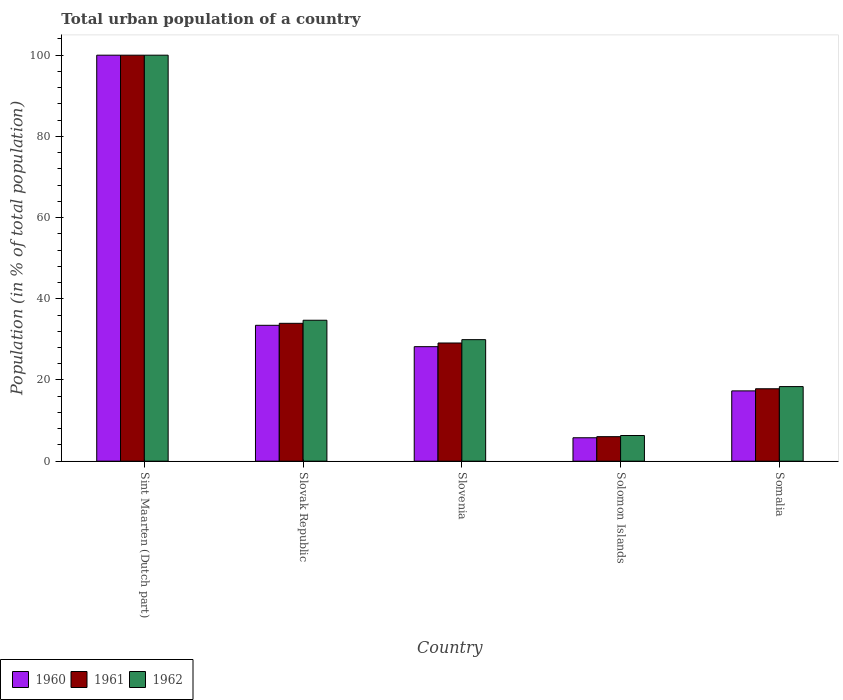How many different coloured bars are there?
Provide a short and direct response. 3. How many groups of bars are there?
Provide a short and direct response. 5. Are the number of bars per tick equal to the number of legend labels?
Offer a terse response. Yes. Are the number of bars on each tick of the X-axis equal?
Keep it short and to the point. Yes. What is the label of the 2nd group of bars from the left?
Offer a terse response. Slovak Republic. What is the urban population in 1960 in Somalia?
Offer a very short reply. 17.31. Across all countries, what is the minimum urban population in 1961?
Your answer should be compact. 6.04. In which country was the urban population in 1962 maximum?
Give a very brief answer. Sint Maarten (Dutch part). In which country was the urban population in 1961 minimum?
Give a very brief answer. Solomon Islands. What is the total urban population in 1962 in the graph?
Your answer should be very brief. 189.34. What is the difference between the urban population in 1961 in Slovenia and that in Somalia?
Offer a terse response. 11.27. What is the difference between the urban population in 1962 in Somalia and the urban population in 1960 in Slovenia?
Provide a short and direct response. -9.83. What is the average urban population in 1960 per country?
Provide a short and direct response. 36.95. What is the difference between the urban population of/in 1961 and urban population of/in 1960 in Solomon Islands?
Give a very brief answer. 0.27. In how many countries, is the urban population in 1960 greater than 80 %?
Offer a very short reply. 1. What is the ratio of the urban population in 1962 in Sint Maarten (Dutch part) to that in Slovak Republic?
Make the answer very short. 2.88. Is the difference between the urban population in 1961 in Slovak Republic and Solomon Islands greater than the difference between the urban population in 1960 in Slovak Republic and Solomon Islands?
Keep it short and to the point. Yes. What is the difference between the highest and the second highest urban population in 1960?
Provide a short and direct response. -66.54. What is the difference between the highest and the lowest urban population in 1962?
Provide a succinct answer. 93.68. What does the 3rd bar from the right in Slovak Republic represents?
Offer a terse response. 1960. Are all the bars in the graph horizontal?
Give a very brief answer. No. How many countries are there in the graph?
Offer a very short reply. 5. Where does the legend appear in the graph?
Offer a very short reply. Bottom left. How many legend labels are there?
Provide a succinct answer. 3. What is the title of the graph?
Offer a very short reply. Total urban population of a country. Does "1981" appear as one of the legend labels in the graph?
Give a very brief answer. No. What is the label or title of the X-axis?
Your answer should be compact. Country. What is the label or title of the Y-axis?
Your answer should be very brief. Population (in % of total population). What is the Population (in % of total population) in 1960 in Slovak Republic?
Offer a very short reply. 33.46. What is the Population (in % of total population) in 1961 in Slovak Republic?
Make the answer very short. 33.95. What is the Population (in % of total population) of 1962 in Slovak Republic?
Provide a succinct answer. 34.71. What is the Population (in % of total population) of 1960 in Slovenia?
Make the answer very short. 28.2. What is the Population (in % of total population) in 1961 in Slovenia?
Offer a terse response. 29.11. What is the Population (in % of total population) of 1962 in Slovenia?
Keep it short and to the point. 29.93. What is the Population (in % of total population) of 1960 in Solomon Islands?
Make the answer very short. 5.77. What is the Population (in % of total population) of 1961 in Solomon Islands?
Provide a succinct answer. 6.04. What is the Population (in % of total population) in 1962 in Solomon Islands?
Make the answer very short. 6.32. What is the Population (in % of total population) of 1960 in Somalia?
Make the answer very short. 17.31. What is the Population (in % of total population) of 1961 in Somalia?
Ensure brevity in your answer.  17.84. What is the Population (in % of total population) in 1962 in Somalia?
Offer a terse response. 18.37. Across all countries, what is the maximum Population (in % of total population) in 1961?
Provide a short and direct response. 100. Across all countries, what is the minimum Population (in % of total population) in 1960?
Offer a terse response. 5.77. Across all countries, what is the minimum Population (in % of total population) in 1961?
Your answer should be compact. 6.04. Across all countries, what is the minimum Population (in % of total population) in 1962?
Keep it short and to the point. 6.32. What is the total Population (in % of total population) of 1960 in the graph?
Your response must be concise. 184.75. What is the total Population (in % of total population) of 1961 in the graph?
Make the answer very short. 186.93. What is the total Population (in % of total population) in 1962 in the graph?
Offer a terse response. 189.34. What is the difference between the Population (in % of total population) in 1960 in Sint Maarten (Dutch part) and that in Slovak Republic?
Your answer should be compact. 66.54. What is the difference between the Population (in % of total population) of 1961 in Sint Maarten (Dutch part) and that in Slovak Republic?
Provide a short and direct response. 66.05. What is the difference between the Population (in % of total population) of 1962 in Sint Maarten (Dutch part) and that in Slovak Republic?
Make the answer very short. 65.29. What is the difference between the Population (in % of total population) of 1960 in Sint Maarten (Dutch part) and that in Slovenia?
Make the answer very short. 71.8. What is the difference between the Population (in % of total population) in 1961 in Sint Maarten (Dutch part) and that in Slovenia?
Make the answer very short. 70.89. What is the difference between the Population (in % of total population) in 1962 in Sint Maarten (Dutch part) and that in Slovenia?
Provide a succinct answer. 70.07. What is the difference between the Population (in % of total population) of 1960 in Sint Maarten (Dutch part) and that in Solomon Islands?
Offer a terse response. 94.23. What is the difference between the Population (in % of total population) in 1961 in Sint Maarten (Dutch part) and that in Solomon Islands?
Provide a succinct answer. 93.96. What is the difference between the Population (in % of total population) of 1962 in Sint Maarten (Dutch part) and that in Solomon Islands?
Offer a very short reply. 93.68. What is the difference between the Population (in % of total population) of 1960 in Sint Maarten (Dutch part) and that in Somalia?
Keep it short and to the point. 82.69. What is the difference between the Population (in % of total population) in 1961 in Sint Maarten (Dutch part) and that in Somalia?
Offer a terse response. 82.17. What is the difference between the Population (in % of total population) of 1962 in Sint Maarten (Dutch part) and that in Somalia?
Give a very brief answer. 81.63. What is the difference between the Population (in % of total population) of 1960 in Slovak Republic and that in Slovenia?
Ensure brevity in your answer.  5.26. What is the difference between the Population (in % of total population) of 1961 in Slovak Republic and that in Slovenia?
Your response must be concise. 4.85. What is the difference between the Population (in % of total population) of 1962 in Slovak Republic and that in Slovenia?
Provide a succinct answer. 4.78. What is the difference between the Population (in % of total population) of 1960 in Slovak Republic and that in Solomon Islands?
Your response must be concise. 27.7. What is the difference between the Population (in % of total population) in 1961 in Slovak Republic and that in Solomon Islands?
Ensure brevity in your answer.  27.91. What is the difference between the Population (in % of total population) in 1962 in Slovak Republic and that in Solomon Islands?
Offer a terse response. 28.39. What is the difference between the Population (in % of total population) of 1960 in Slovak Republic and that in Somalia?
Ensure brevity in your answer.  16.15. What is the difference between the Population (in % of total population) in 1961 in Slovak Republic and that in Somalia?
Your response must be concise. 16.12. What is the difference between the Population (in % of total population) of 1962 in Slovak Republic and that in Somalia?
Your answer should be compact. 16.34. What is the difference between the Population (in % of total population) in 1960 in Slovenia and that in Solomon Islands?
Offer a very short reply. 22.44. What is the difference between the Population (in % of total population) in 1961 in Slovenia and that in Solomon Islands?
Provide a succinct answer. 23.07. What is the difference between the Population (in % of total population) in 1962 in Slovenia and that in Solomon Islands?
Provide a short and direct response. 23.61. What is the difference between the Population (in % of total population) in 1960 in Slovenia and that in Somalia?
Provide a short and direct response. 10.89. What is the difference between the Population (in % of total population) of 1961 in Slovenia and that in Somalia?
Offer a very short reply. 11.27. What is the difference between the Population (in % of total population) of 1962 in Slovenia and that in Somalia?
Provide a succinct answer. 11.56. What is the difference between the Population (in % of total population) of 1960 in Solomon Islands and that in Somalia?
Offer a terse response. -11.54. What is the difference between the Population (in % of total population) in 1961 in Solomon Islands and that in Somalia?
Provide a succinct answer. -11.8. What is the difference between the Population (in % of total population) in 1962 in Solomon Islands and that in Somalia?
Offer a very short reply. -12.05. What is the difference between the Population (in % of total population) of 1960 in Sint Maarten (Dutch part) and the Population (in % of total population) of 1961 in Slovak Republic?
Ensure brevity in your answer.  66.05. What is the difference between the Population (in % of total population) of 1960 in Sint Maarten (Dutch part) and the Population (in % of total population) of 1962 in Slovak Republic?
Make the answer very short. 65.29. What is the difference between the Population (in % of total population) in 1961 in Sint Maarten (Dutch part) and the Population (in % of total population) in 1962 in Slovak Republic?
Offer a very short reply. 65.29. What is the difference between the Population (in % of total population) of 1960 in Sint Maarten (Dutch part) and the Population (in % of total population) of 1961 in Slovenia?
Keep it short and to the point. 70.89. What is the difference between the Population (in % of total population) of 1960 in Sint Maarten (Dutch part) and the Population (in % of total population) of 1962 in Slovenia?
Make the answer very short. 70.07. What is the difference between the Population (in % of total population) in 1961 in Sint Maarten (Dutch part) and the Population (in % of total population) in 1962 in Slovenia?
Provide a short and direct response. 70.07. What is the difference between the Population (in % of total population) of 1960 in Sint Maarten (Dutch part) and the Population (in % of total population) of 1961 in Solomon Islands?
Your answer should be compact. 93.96. What is the difference between the Population (in % of total population) in 1960 in Sint Maarten (Dutch part) and the Population (in % of total population) in 1962 in Solomon Islands?
Give a very brief answer. 93.68. What is the difference between the Population (in % of total population) of 1961 in Sint Maarten (Dutch part) and the Population (in % of total population) of 1962 in Solomon Islands?
Provide a short and direct response. 93.68. What is the difference between the Population (in % of total population) of 1960 in Sint Maarten (Dutch part) and the Population (in % of total population) of 1961 in Somalia?
Your answer should be very brief. 82.17. What is the difference between the Population (in % of total population) in 1960 in Sint Maarten (Dutch part) and the Population (in % of total population) in 1962 in Somalia?
Your answer should be compact. 81.63. What is the difference between the Population (in % of total population) in 1961 in Sint Maarten (Dutch part) and the Population (in % of total population) in 1962 in Somalia?
Offer a terse response. 81.63. What is the difference between the Population (in % of total population) of 1960 in Slovak Republic and the Population (in % of total population) of 1961 in Slovenia?
Your answer should be compact. 4.36. What is the difference between the Population (in % of total population) in 1960 in Slovak Republic and the Population (in % of total population) in 1962 in Slovenia?
Keep it short and to the point. 3.53. What is the difference between the Population (in % of total population) of 1961 in Slovak Republic and the Population (in % of total population) of 1962 in Slovenia?
Provide a succinct answer. 4.02. What is the difference between the Population (in % of total population) of 1960 in Slovak Republic and the Population (in % of total population) of 1961 in Solomon Islands?
Give a very brief answer. 27.43. What is the difference between the Population (in % of total population) in 1960 in Slovak Republic and the Population (in % of total population) in 1962 in Solomon Islands?
Ensure brevity in your answer.  27.14. What is the difference between the Population (in % of total population) of 1961 in Slovak Republic and the Population (in % of total population) of 1962 in Solomon Islands?
Give a very brief answer. 27.63. What is the difference between the Population (in % of total population) in 1960 in Slovak Republic and the Population (in % of total population) in 1961 in Somalia?
Your answer should be compact. 15.63. What is the difference between the Population (in % of total population) in 1960 in Slovak Republic and the Population (in % of total population) in 1962 in Somalia?
Your answer should be very brief. 15.09. What is the difference between the Population (in % of total population) of 1961 in Slovak Republic and the Population (in % of total population) of 1962 in Somalia?
Give a very brief answer. 15.58. What is the difference between the Population (in % of total population) of 1960 in Slovenia and the Population (in % of total population) of 1961 in Solomon Islands?
Make the answer very short. 22.17. What is the difference between the Population (in % of total population) of 1960 in Slovenia and the Population (in % of total population) of 1962 in Solomon Islands?
Provide a short and direct response. 21.88. What is the difference between the Population (in % of total population) in 1961 in Slovenia and the Population (in % of total population) in 1962 in Solomon Islands?
Ensure brevity in your answer.  22.79. What is the difference between the Population (in % of total population) in 1960 in Slovenia and the Population (in % of total population) in 1961 in Somalia?
Make the answer very short. 10.37. What is the difference between the Population (in % of total population) in 1960 in Slovenia and the Population (in % of total population) in 1962 in Somalia?
Keep it short and to the point. 9.83. What is the difference between the Population (in % of total population) of 1961 in Slovenia and the Population (in % of total population) of 1962 in Somalia?
Your answer should be compact. 10.73. What is the difference between the Population (in % of total population) in 1960 in Solomon Islands and the Population (in % of total population) in 1961 in Somalia?
Offer a terse response. -12.07. What is the difference between the Population (in % of total population) in 1960 in Solomon Islands and the Population (in % of total population) in 1962 in Somalia?
Offer a very short reply. -12.6. What is the difference between the Population (in % of total population) of 1961 in Solomon Islands and the Population (in % of total population) of 1962 in Somalia?
Provide a short and direct response. -12.33. What is the average Population (in % of total population) of 1960 per country?
Your answer should be very brief. 36.95. What is the average Population (in % of total population) of 1961 per country?
Ensure brevity in your answer.  37.39. What is the average Population (in % of total population) in 1962 per country?
Make the answer very short. 37.87. What is the difference between the Population (in % of total population) in 1960 and Population (in % of total population) in 1961 in Sint Maarten (Dutch part)?
Offer a terse response. 0. What is the difference between the Population (in % of total population) in 1960 and Population (in % of total population) in 1962 in Sint Maarten (Dutch part)?
Your response must be concise. 0. What is the difference between the Population (in % of total population) of 1961 and Population (in % of total population) of 1962 in Sint Maarten (Dutch part)?
Provide a succinct answer. 0. What is the difference between the Population (in % of total population) of 1960 and Population (in % of total population) of 1961 in Slovak Republic?
Your response must be concise. -0.49. What is the difference between the Population (in % of total population) of 1960 and Population (in % of total population) of 1962 in Slovak Republic?
Your response must be concise. -1.25. What is the difference between the Population (in % of total population) in 1961 and Population (in % of total population) in 1962 in Slovak Republic?
Ensure brevity in your answer.  -0.76. What is the difference between the Population (in % of total population) of 1960 and Population (in % of total population) of 1961 in Slovenia?
Your answer should be very brief. -0.9. What is the difference between the Population (in % of total population) in 1960 and Population (in % of total population) in 1962 in Slovenia?
Your answer should be compact. -1.73. What is the difference between the Population (in % of total population) of 1961 and Population (in % of total population) of 1962 in Slovenia?
Offer a very short reply. -0.83. What is the difference between the Population (in % of total population) in 1960 and Population (in % of total population) in 1961 in Solomon Islands?
Offer a very short reply. -0.27. What is the difference between the Population (in % of total population) in 1960 and Population (in % of total population) in 1962 in Solomon Islands?
Offer a terse response. -0.55. What is the difference between the Population (in % of total population) in 1961 and Population (in % of total population) in 1962 in Solomon Islands?
Provide a short and direct response. -0.28. What is the difference between the Population (in % of total population) of 1960 and Population (in % of total population) of 1961 in Somalia?
Provide a succinct answer. -0.52. What is the difference between the Population (in % of total population) in 1960 and Population (in % of total population) in 1962 in Somalia?
Provide a short and direct response. -1.06. What is the difference between the Population (in % of total population) in 1961 and Population (in % of total population) in 1962 in Somalia?
Your response must be concise. -0.54. What is the ratio of the Population (in % of total population) of 1960 in Sint Maarten (Dutch part) to that in Slovak Republic?
Keep it short and to the point. 2.99. What is the ratio of the Population (in % of total population) in 1961 in Sint Maarten (Dutch part) to that in Slovak Republic?
Provide a short and direct response. 2.95. What is the ratio of the Population (in % of total population) in 1962 in Sint Maarten (Dutch part) to that in Slovak Republic?
Offer a terse response. 2.88. What is the ratio of the Population (in % of total population) in 1960 in Sint Maarten (Dutch part) to that in Slovenia?
Make the answer very short. 3.55. What is the ratio of the Population (in % of total population) of 1961 in Sint Maarten (Dutch part) to that in Slovenia?
Your answer should be compact. 3.44. What is the ratio of the Population (in % of total population) of 1962 in Sint Maarten (Dutch part) to that in Slovenia?
Provide a short and direct response. 3.34. What is the ratio of the Population (in % of total population) of 1960 in Sint Maarten (Dutch part) to that in Solomon Islands?
Offer a terse response. 17.34. What is the ratio of the Population (in % of total population) in 1961 in Sint Maarten (Dutch part) to that in Solomon Islands?
Your answer should be very brief. 16.56. What is the ratio of the Population (in % of total population) in 1962 in Sint Maarten (Dutch part) to that in Solomon Islands?
Your response must be concise. 15.82. What is the ratio of the Population (in % of total population) of 1960 in Sint Maarten (Dutch part) to that in Somalia?
Provide a succinct answer. 5.78. What is the ratio of the Population (in % of total population) in 1961 in Sint Maarten (Dutch part) to that in Somalia?
Provide a succinct answer. 5.61. What is the ratio of the Population (in % of total population) of 1962 in Sint Maarten (Dutch part) to that in Somalia?
Your response must be concise. 5.44. What is the ratio of the Population (in % of total population) in 1960 in Slovak Republic to that in Slovenia?
Offer a terse response. 1.19. What is the ratio of the Population (in % of total population) in 1961 in Slovak Republic to that in Slovenia?
Keep it short and to the point. 1.17. What is the ratio of the Population (in % of total population) in 1962 in Slovak Republic to that in Slovenia?
Offer a terse response. 1.16. What is the ratio of the Population (in % of total population) in 1960 in Slovak Republic to that in Solomon Islands?
Your response must be concise. 5.8. What is the ratio of the Population (in % of total population) of 1961 in Slovak Republic to that in Solomon Islands?
Keep it short and to the point. 5.62. What is the ratio of the Population (in % of total population) of 1962 in Slovak Republic to that in Solomon Islands?
Give a very brief answer. 5.49. What is the ratio of the Population (in % of total population) in 1960 in Slovak Republic to that in Somalia?
Provide a short and direct response. 1.93. What is the ratio of the Population (in % of total population) of 1961 in Slovak Republic to that in Somalia?
Make the answer very short. 1.9. What is the ratio of the Population (in % of total population) in 1962 in Slovak Republic to that in Somalia?
Give a very brief answer. 1.89. What is the ratio of the Population (in % of total population) in 1960 in Slovenia to that in Solomon Islands?
Your answer should be very brief. 4.89. What is the ratio of the Population (in % of total population) of 1961 in Slovenia to that in Solomon Islands?
Your answer should be very brief. 4.82. What is the ratio of the Population (in % of total population) of 1962 in Slovenia to that in Solomon Islands?
Keep it short and to the point. 4.74. What is the ratio of the Population (in % of total population) of 1960 in Slovenia to that in Somalia?
Your answer should be compact. 1.63. What is the ratio of the Population (in % of total population) of 1961 in Slovenia to that in Somalia?
Keep it short and to the point. 1.63. What is the ratio of the Population (in % of total population) of 1962 in Slovenia to that in Somalia?
Your answer should be very brief. 1.63. What is the ratio of the Population (in % of total population) in 1960 in Solomon Islands to that in Somalia?
Offer a terse response. 0.33. What is the ratio of the Population (in % of total population) in 1961 in Solomon Islands to that in Somalia?
Your response must be concise. 0.34. What is the ratio of the Population (in % of total population) of 1962 in Solomon Islands to that in Somalia?
Keep it short and to the point. 0.34. What is the difference between the highest and the second highest Population (in % of total population) of 1960?
Provide a succinct answer. 66.54. What is the difference between the highest and the second highest Population (in % of total population) of 1961?
Keep it short and to the point. 66.05. What is the difference between the highest and the second highest Population (in % of total population) of 1962?
Provide a short and direct response. 65.29. What is the difference between the highest and the lowest Population (in % of total population) of 1960?
Offer a very short reply. 94.23. What is the difference between the highest and the lowest Population (in % of total population) in 1961?
Make the answer very short. 93.96. What is the difference between the highest and the lowest Population (in % of total population) of 1962?
Your answer should be compact. 93.68. 